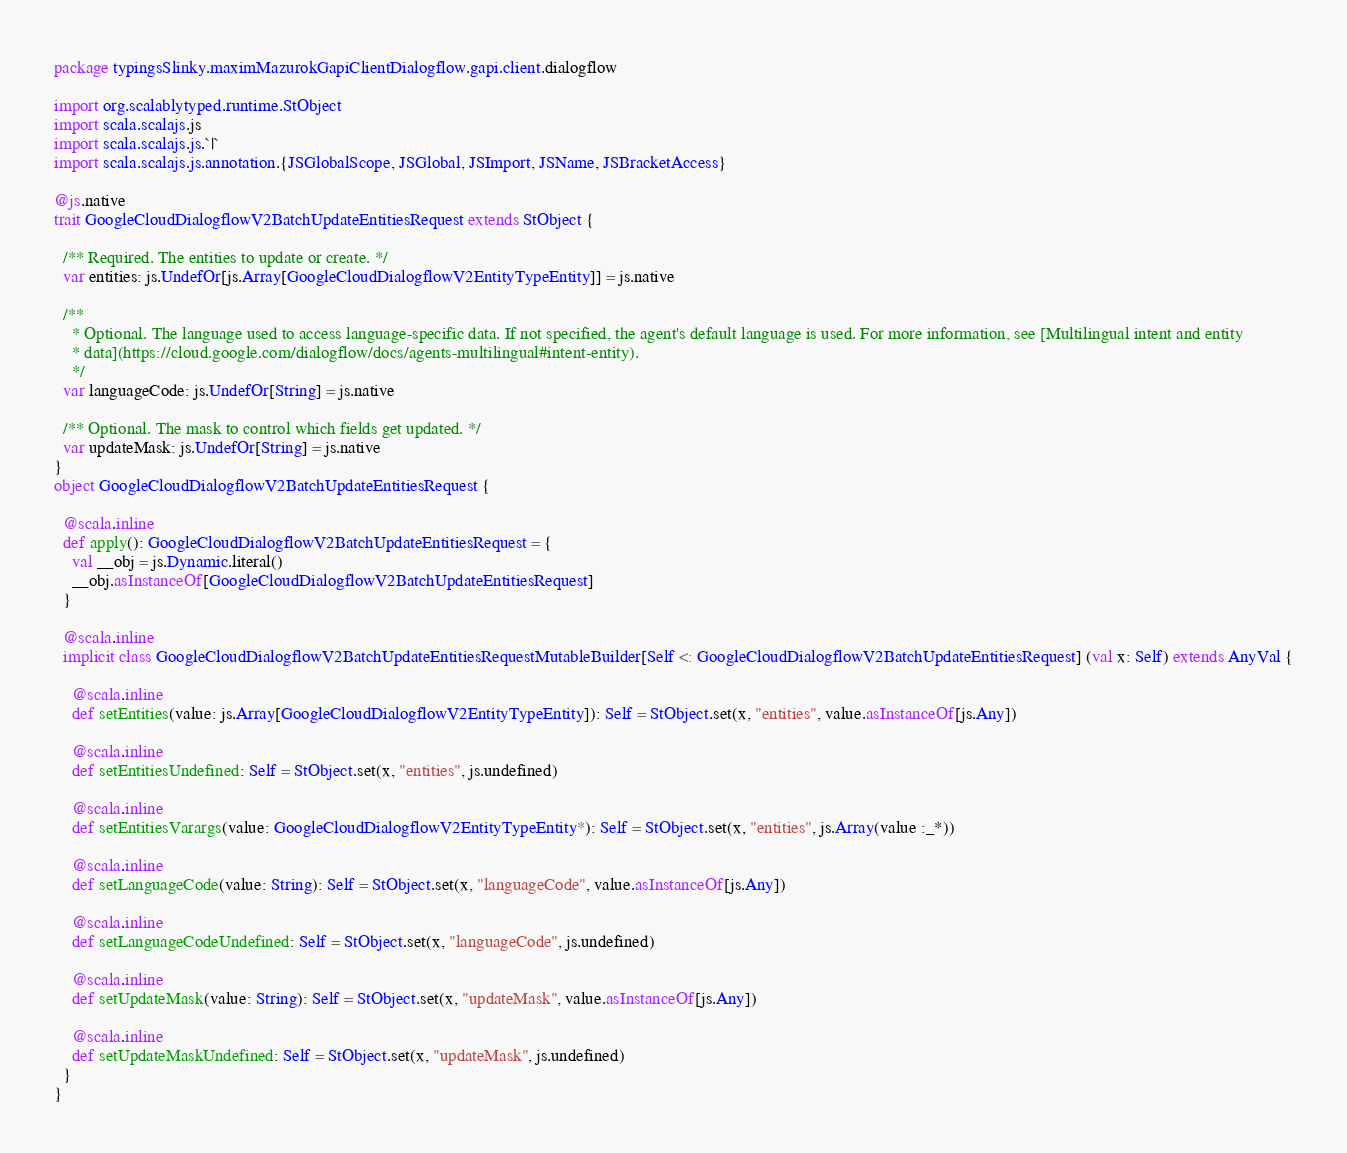Convert code to text. <code><loc_0><loc_0><loc_500><loc_500><_Scala_>package typingsSlinky.maximMazurokGapiClientDialogflow.gapi.client.dialogflow

import org.scalablytyped.runtime.StObject
import scala.scalajs.js
import scala.scalajs.js.`|`
import scala.scalajs.js.annotation.{JSGlobalScope, JSGlobal, JSImport, JSName, JSBracketAccess}

@js.native
trait GoogleCloudDialogflowV2BatchUpdateEntitiesRequest extends StObject {
  
  /** Required. The entities to update or create. */
  var entities: js.UndefOr[js.Array[GoogleCloudDialogflowV2EntityTypeEntity]] = js.native
  
  /**
    * Optional. The language used to access language-specific data. If not specified, the agent's default language is used. For more information, see [Multilingual intent and entity
    * data](https://cloud.google.com/dialogflow/docs/agents-multilingual#intent-entity).
    */
  var languageCode: js.UndefOr[String] = js.native
  
  /** Optional. The mask to control which fields get updated. */
  var updateMask: js.UndefOr[String] = js.native
}
object GoogleCloudDialogflowV2BatchUpdateEntitiesRequest {
  
  @scala.inline
  def apply(): GoogleCloudDialogflowV2BatchUpdateEntitiesRequest = {
    val __obj = js.Dynamic.literal()
    __obj.asInstanceOf[GoogleCloudDialogflowV2BatchUpdateEntitiesRequest]
  }
  
  @scala.inline
  implicit class GoogleCloudDialogflowV2BatchUpdateEntitiesRequestMutableBuilder[Self <: GoogleCloudDialogflowV2BatchUpdateEntitiesRequest] (val x: Self) extends AnyVal {
    
    @scala.inline
    def setEntities(value: js.Array[GoogleCloudDialogflowV2EntityTypeEntity]): Self = StObject.set(x, "entities", value.asInstanceOf[js.Any])
    
    @scala.inline
    def setEntitiesUndefined: Self = StObject.set(x, "entities", js.undefined)
    
    @scala.inline
    def setEntitiesVarargs(value: GoogleCloudDialogflowV2EntityTypeEntity*): Self = StObject.set(x, "entities", js.Array(value :_*))
    
    @scala.inline
    def setLanguageCode(value: String): Self = StObject.set(x, "languageCode", value.asInstanceOf[js.Any])
    
    @scala.inline
    def setLanguageCodeUndefined: Self = StObject.set(x, "languageCode", js.undefined)
    
    @scala.inline
    def setUpdateMask(value: String): Self = StObject.set(x, "updateMask", value.asInstanceOf[js.Any])
    
    @scala.inline
    def setUpdateMaskUndefined: Self = StObject.set(x, "updateMask", js.undefined)
  }
}
</code> 